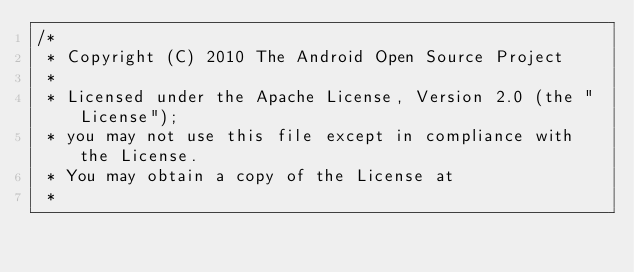<code> <loc_0><loc_0><loc_500><loc_500><_C_>/*
 * Copyright (C) 2010 The Android Open Source Project
 *
 * Licensed under the Apache License, Version 2.0 (the "License");
 * you may not use this file except in compliance with the License.
 * You may obtain a copy of the License at
 *</code> 